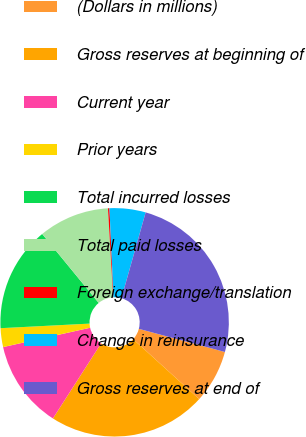<chart> <loc_0><loc_0><loc_500><loc_500><pie_chart><fcel>(Dollars in millions)<fcel>Gross reserves at beginning of<fcel>Current year<fcel>Prior years<fcel>Total incurred losses<fcel>Total paid losses<fcel>Foreign exchange/translation<fcel>Change in reinsurance<fcel>Gross reserves at end of<nl><fcel>7.55%<fcel>22.35%<fcel>12.44%<fcel>2.66%<fcel>14.89%<fcel>10.0%<fcel>0.21%<fcel>5.1%<fcel>24.8%<nl></chart> 